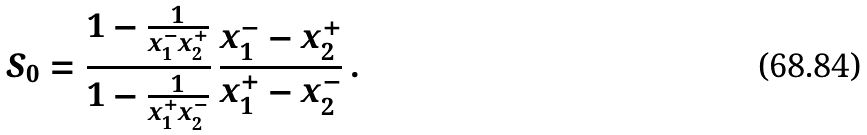<formula> <loc_0><loc_0><loc_500><loc_500>S _ { 0 } = \frac { 1 - \frac { 1 } { x _ { 1 } ^ { - } x _ { 2 } ^ { + } } } { 1 - \frac { 1 } { x _ { 1 } ^ { + } x _ { 2 } ^ { - } } } \, \frac { x _ { 1 } ^ { - } - x _ { 2 } ^ { + } } { x _ { 1 } ^ { + } - x _ { 2 } ^ { - } } \, .</formula> 